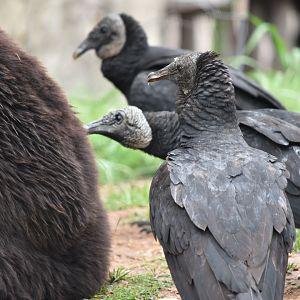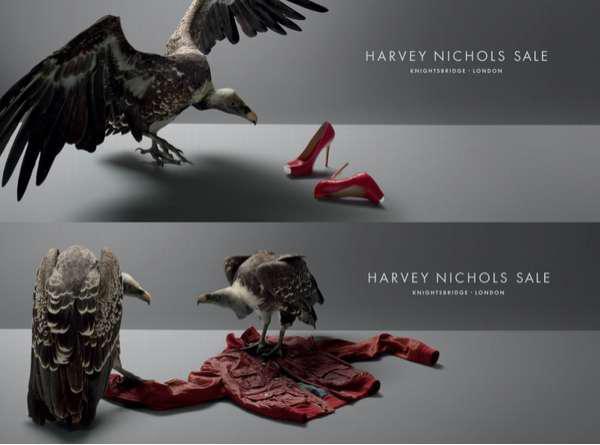The first image is the image on the left, the second image is the image on the right. Assess this claim about the two images: "An image shows vultures next to a zebra carcass.". Correct or not? Answer yes or no. No. The first image is the image on the left, the second image is the image on the right. Considering the images on both sides, is "A single bird is standing on a stump in the image on the right." valid? Answer yes or no. No. 